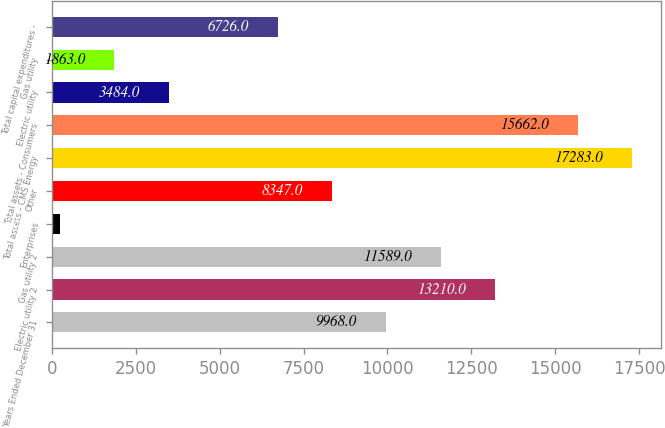Convert chart to OTSL. <chart><loc_0><loc_0><loc_500><loc_500><bar_chart><fcel>Years Ended December 31<fcel>Electric utility 2<fcel>Gas utility 2<fcel>Enterprises<fcel>Other<fcel>Total assets - CMS Energy<fcel>Total assets - Consumers<fcel>Electric utility<fcel>Gas utility<fcel>Total capital expenditures -<nl><fcel>9968<fcel>13210<fcel>11589<fcel>242<fcel>8347<fcel>17283<fcel>15662<fcel>3484<fcel>1863<fcel>6726<nl></chart> 